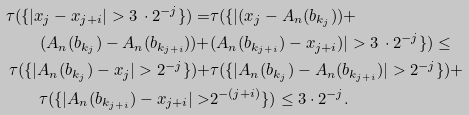<formula> <loc_0><loc_0><loc_500><loc_500>\tau ( \{ | x _ { j } - x _ { j + i } | > 3 \, \cdot 2 ^ { - j } \} ) = & \tau ( \{ | ( x _ { j } - A _ { n } ( b _ { k _ { j } } ) ) + \\ ( A _ { n } ( b _ { k _ { j } } ) - A _ { n } ( b _ { k _ { j + i } } ) ) + & ( A _ { n } ( b _ { k _ { j + i } } ) - x _ { j + i } ) | > 3 \, \cdot 2 ^ { - j } \} ) \leq \\ \tau ( \{ | A _ { n } ( b _ { k _ { j } } ) - x _ { j } | > 2 ^ { - j } \} ) + & \tau ( \{ | A _ { n } ( b _ { k _ { j } } ) - A _ { n } ( b _ { k _ { j + i } } ) | > 2 ^ { - j } \} ) + \\ \tau ( \{ | A _ { n } ( b _ { k _ { j + i } } ) - x _ { j + i } | > & 2 ^ { - ( j + i ) } \} ) \leq 3 \cdot 2 ^ { - j } .</formula> 